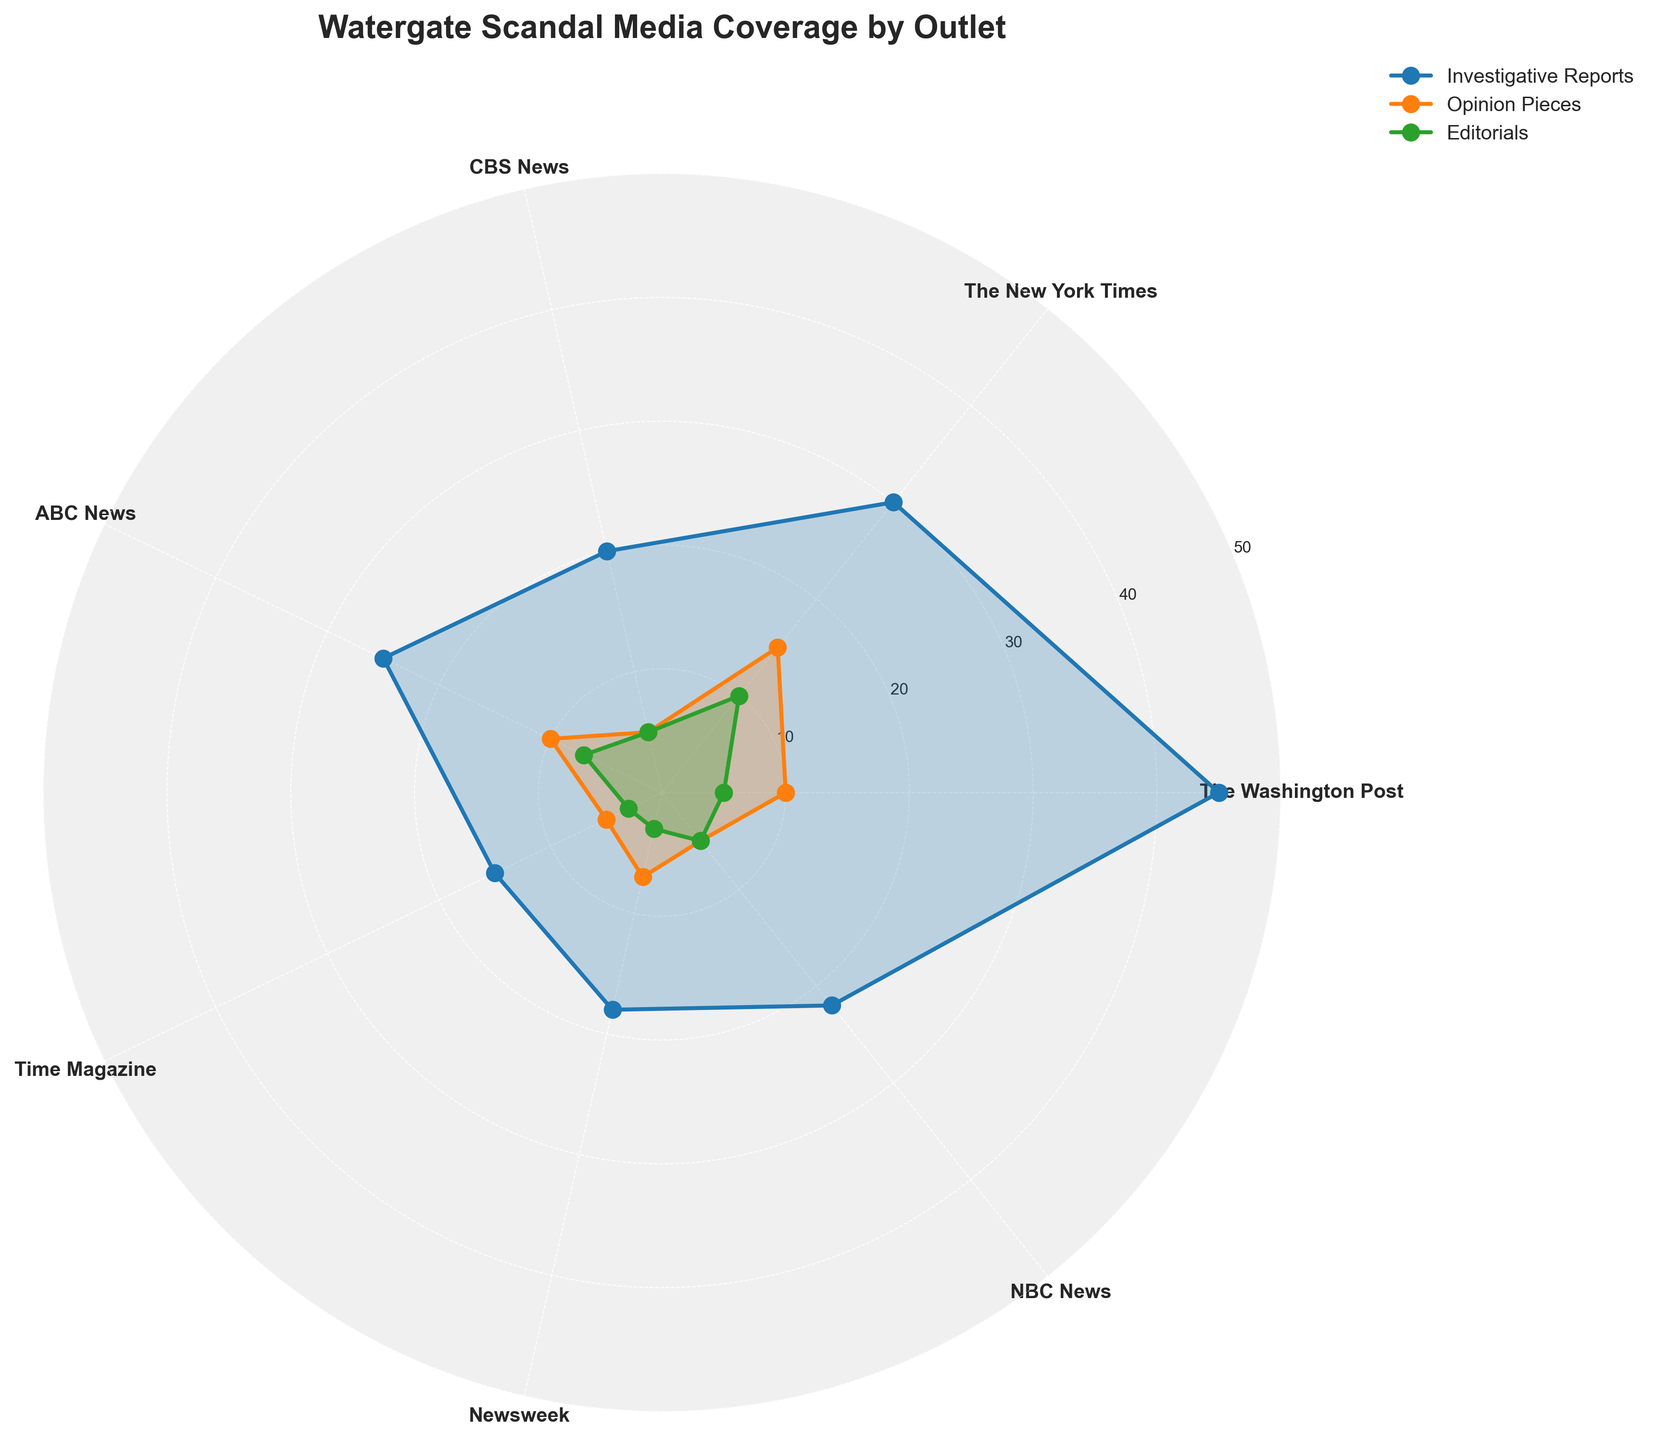What is the title of the chart? The title is located at the top of the chart and reads "Watergate Scandal Media Coverage by Outlet".
Answer: Watergate Scandal Media Coverage by Outlet Which media outlet has the highest number of investigative reports? Investigative Reports are plotted and filled with a different color for each outlet. By checking each one, The Washington Post has the highest number with 45.
Answer: The Washington Post How many types of media coverage are represented in the chart? The legend shows different categories of media coverage represented by different colors: Investigative Reports, Opinion Pieces, and Editorials.
Answer: 3 What is the total number of Opinion Pieces across all outlets? Sum the count of Opinion Pieces for each outlet: The Washington Post (10) + The New York Times (15) + CBS News (5) + ABC News (10) + Time Magazine (5) + Newsweek (7) + NBC News (5): 10 + 15 + 5 + 10 + 5 + 7 + 5 = 57.
Answer: 57 Which media outlet has the least number of Editorials, and how many? Editorials are generally shown in their specific color. Time Magazine and Newsweek both have 3 Editorials, which is the lowest.
Answer: Time Magazine and Newsweek, 3 each Compare the number of Investigative Reports between The New York Times and NBC News. Which has more, and by how much? Investigative Reports for The New York Times is 30, and for NBC News, it is 22. The difference is 30 - 22 = 8.
Answer: The New York Times, by 8 Which category of media coverage has the most variation across different outlets? Analyzing the plot for range and spread of each category, Investigative Reports vary the most, ranging from 15 to 45.
Answer: Investigative Reports If you average the number of Editorials across all outlets, what is the result? Take the Editorial counts: 5, 10, 5, 7, 3, 3, 5. Sum them: 5 + 10 + 5 + 7 + 3 + 3 + 5 = 38. There are 7 outlets, so divide the sum by 7: 38 / 7 ≈ 5.43.
Answer: 5.43 Is there any outlet with equal numbers of Investigative Reports and Opinion Pieces? Check each outlet's categories: None of the outlets have equal numbers for these two categories.
Answer: No 